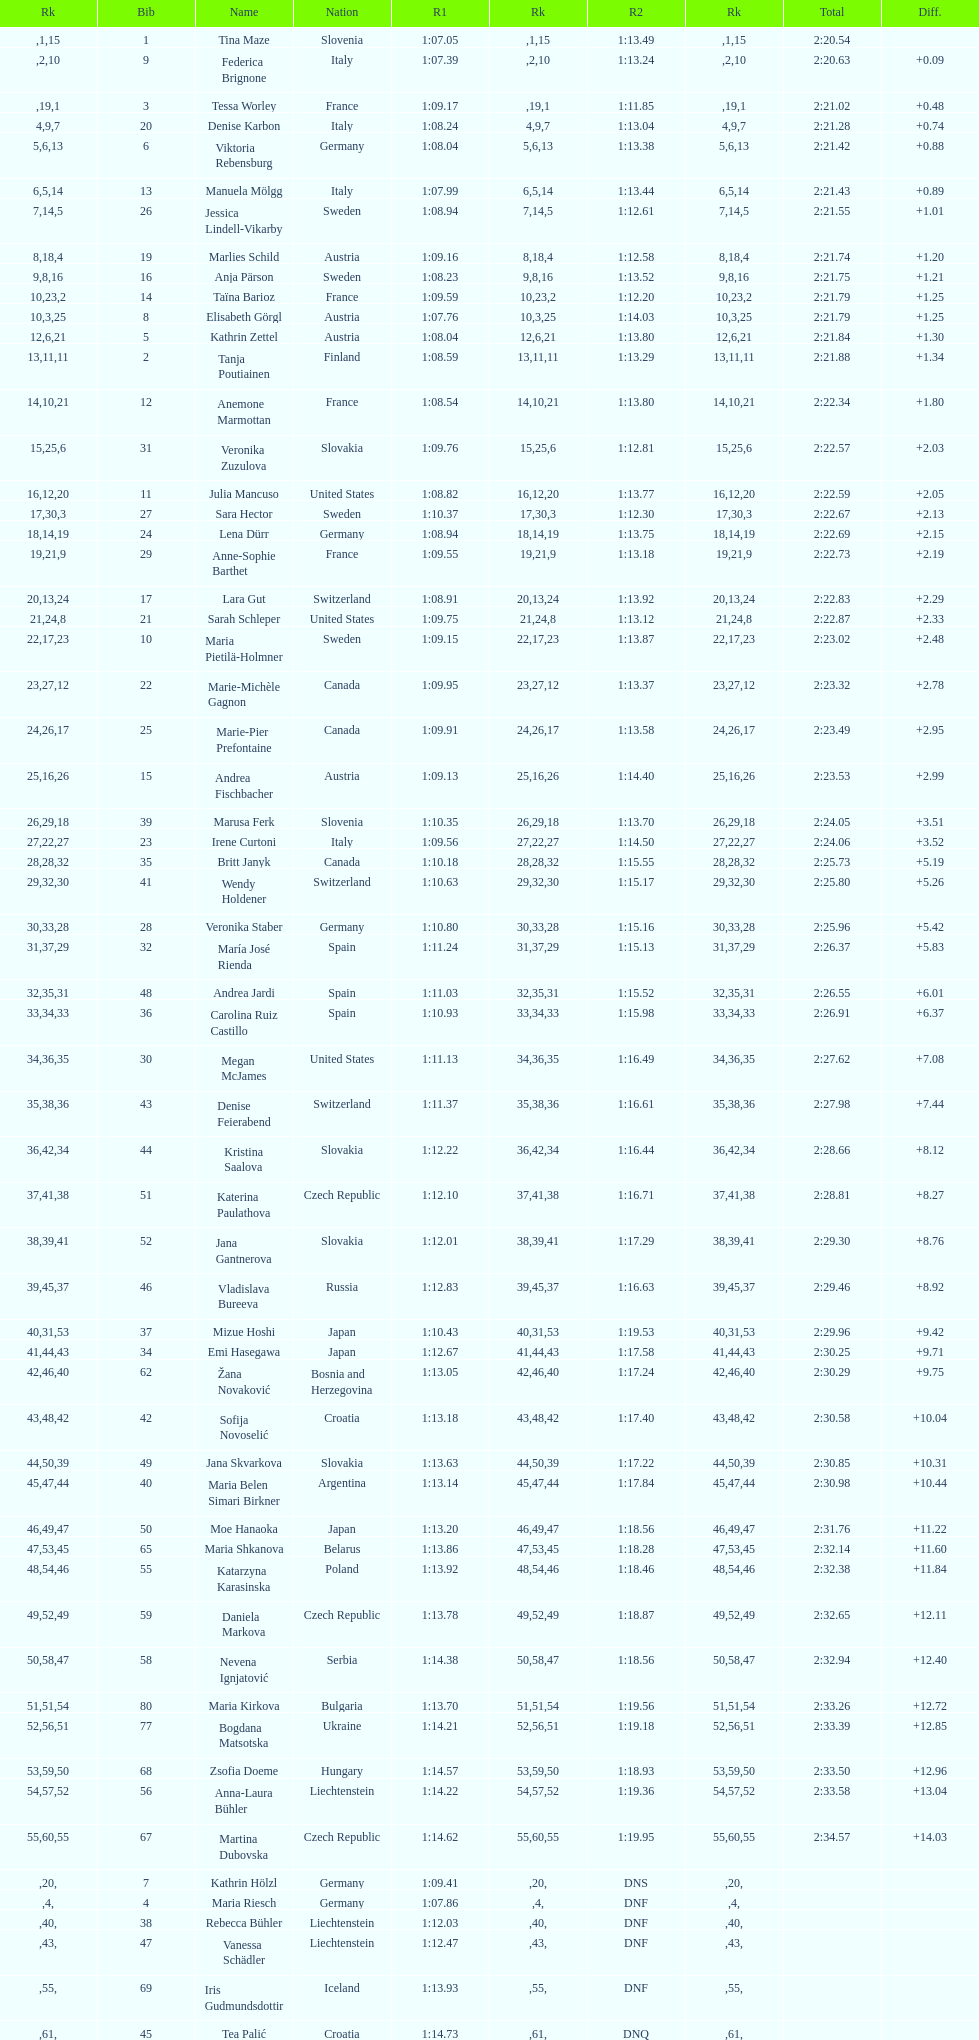How long did it take tina maze to finish the race? 2:20.54. 